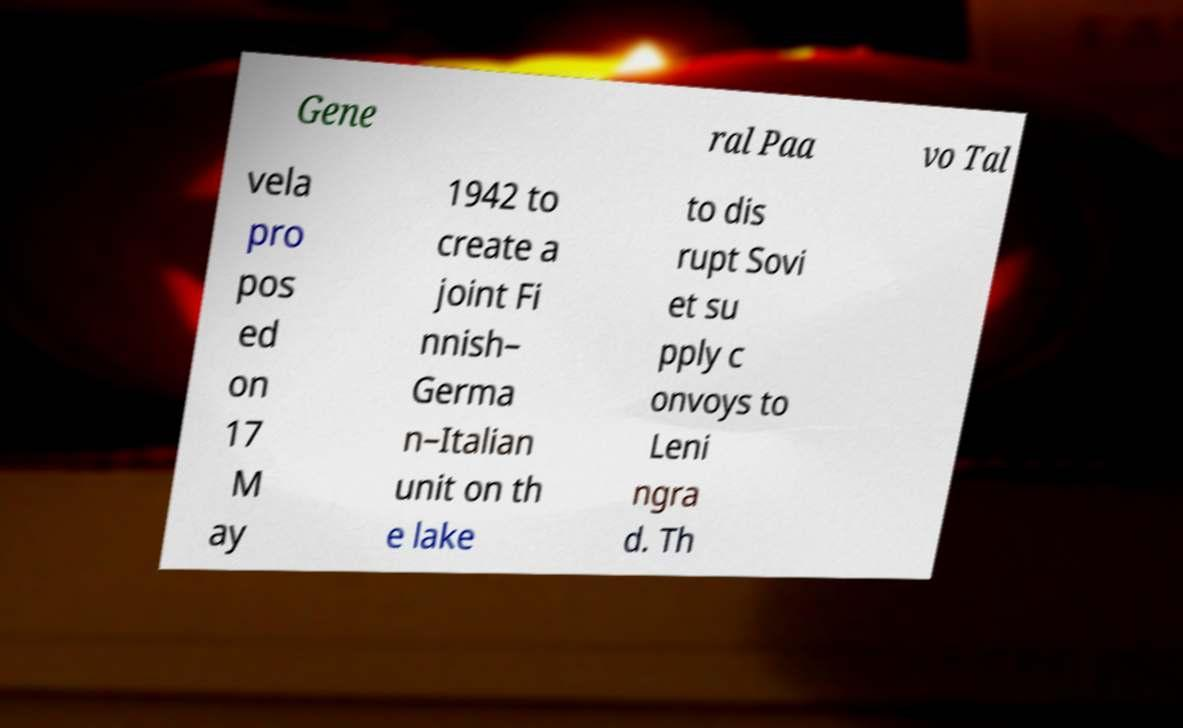Can you accurately transcribe the text from the provided image for me? Gene ral Paa vo Tal vela pro pos ed on 17 M ay 1942 to create a joint Fi nnish– Germa n–Italian unit on th e lake to dis rupt Sovi et su pply c onvoys to Leni ngra d. Th 